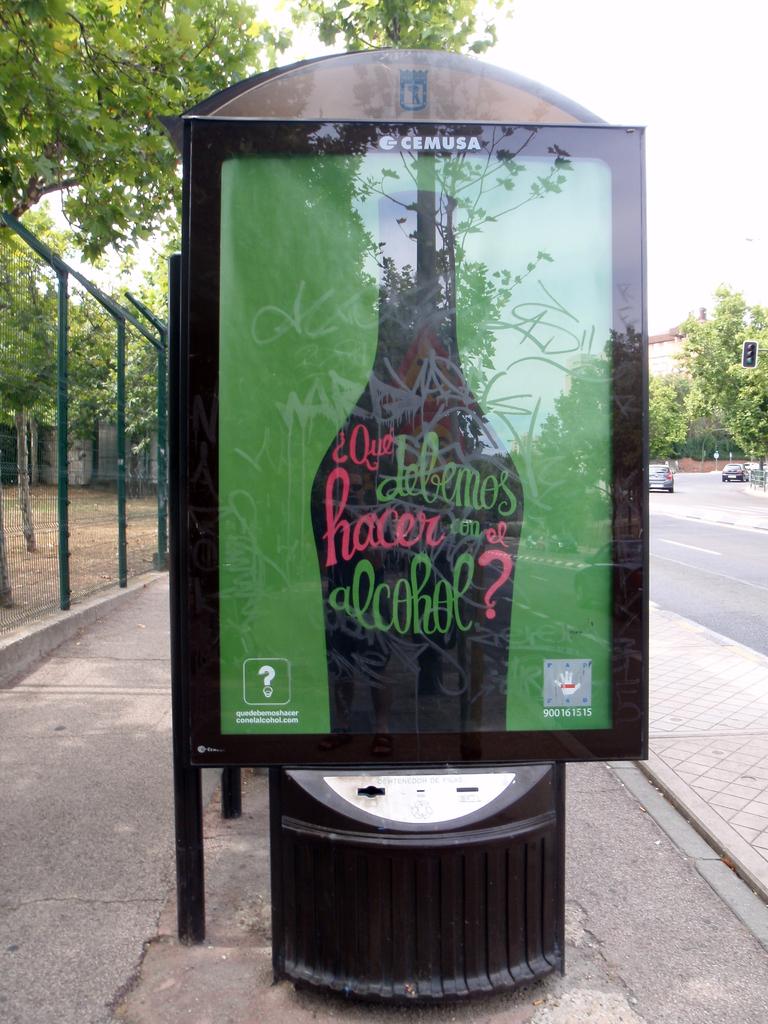What colour is the text?
Make the answer very short. Answering does not require reading text in the image. What is the last word in green?
Your response must be concise. Alcohol. 